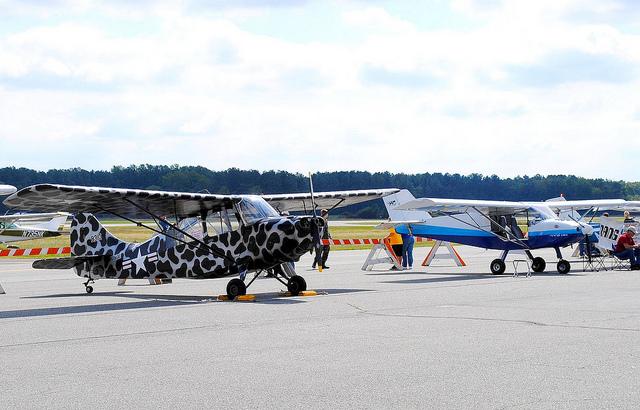What design is painted on the plane?
Write a very short answer. Giraffe. Are these planes in motion?
Be succinct. No. What is in the background?
Keep it brief. Trees. 